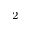Convert formula to latex. <formula><loc_0><loc_0><loc_500><loc_500>^ { 2 }</formula> 